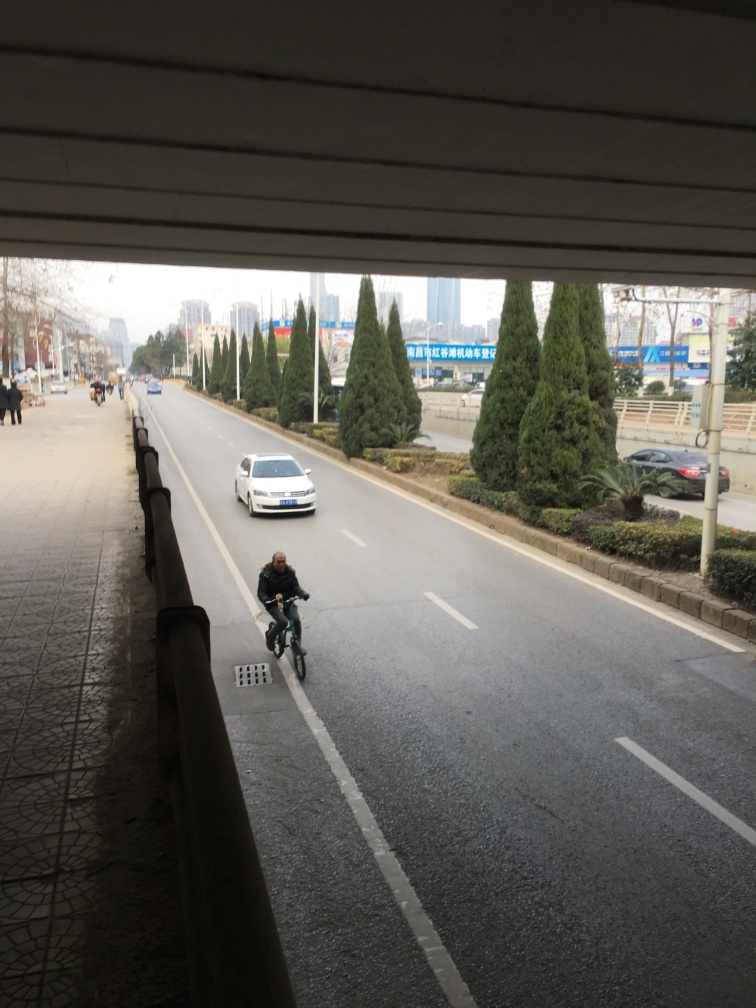Can you describe the setting of this image? The image shows an urban environment with a broad street flanked by sidewalks and rows of neatly planted trees. The presence of vehicles and the building structures in the distance suggest a modern cityscape. Are there any notable landmarks or signs that might hint at the location? There are no immediately recognizable landmarks in the image, but the signs and architectural style might offer clues to the discerning viewer about the geographical location. 